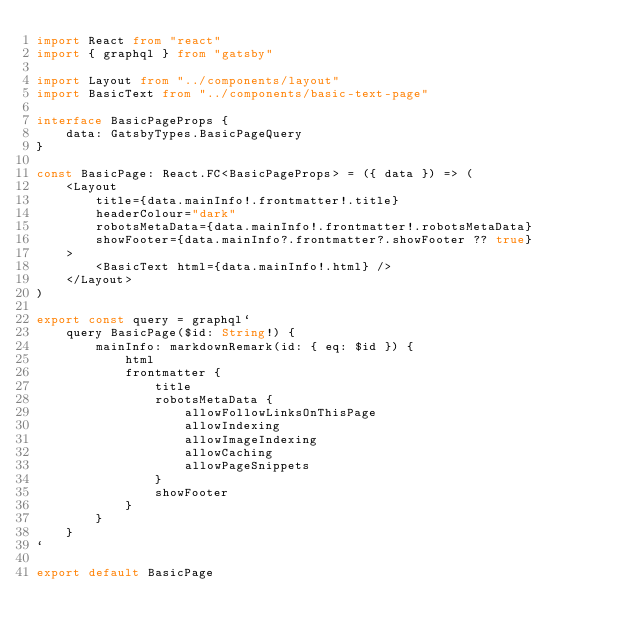Convert code to text. <code><loc_0><loc_0><loc_500><loc_500><_TypeScript_>import React from "react"
import { graphql } from "gatsby"

import Layout from "../components/layout"
import BasicText from "../components/basic-text-page"

interface BasicPageProps {
    data: GatsbyTypes.BasicPageQuery
}

const BasicPage: React.FC<BasicPageProps> = ({ data }) => (
    <Layout
        title={data.mainInfo!.frontmatter!.title}
        headerColour="dark"
        robotsMetaData={data.mainInfo!.frontmatter!.robotsMetaData}
        showFooter={data.mainInfo?.frontmatter?.showFooter ?? true}
    >
        <BasicText html={data.mainInfo!.html} />
    </Layout>
)

export const query = graphql`
    query BasicPage($id: String!) {
        mainInfo: markdownRemark(id: { eq: $id }) {
            html
            frontmatter {
                title
                robotsMetaData {
                    allowFollowLinksOnThisPage
                    allowIndexing
                    allowImageIndexing
                    allowCaching
                    allowPageSnippets
                }
                showFooter
            }
        }
    }
`

export default BasicPage
</code> 